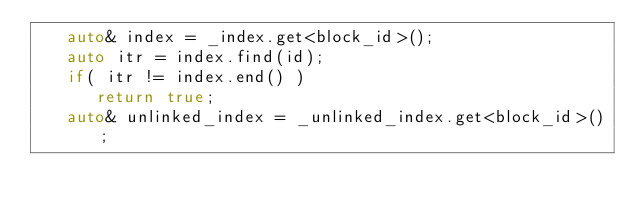<code> <loc_0><loc_0><loc_500><loc_500><_C++_>   auto& index = _index.get<block_id>();
   auto itr = index.find(id);
   if( itr != index.end() )
      return true;
   auto& unlinked_index = _unlinked_index.get<block_id>();</code> 